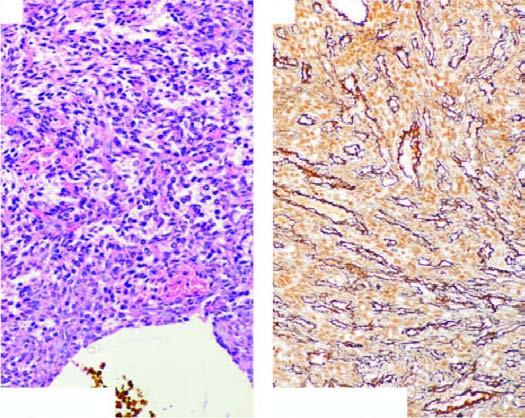do these tumour cells have bland nuclei and few mitoses?
Answer the question using a single word or phrase. Yes 